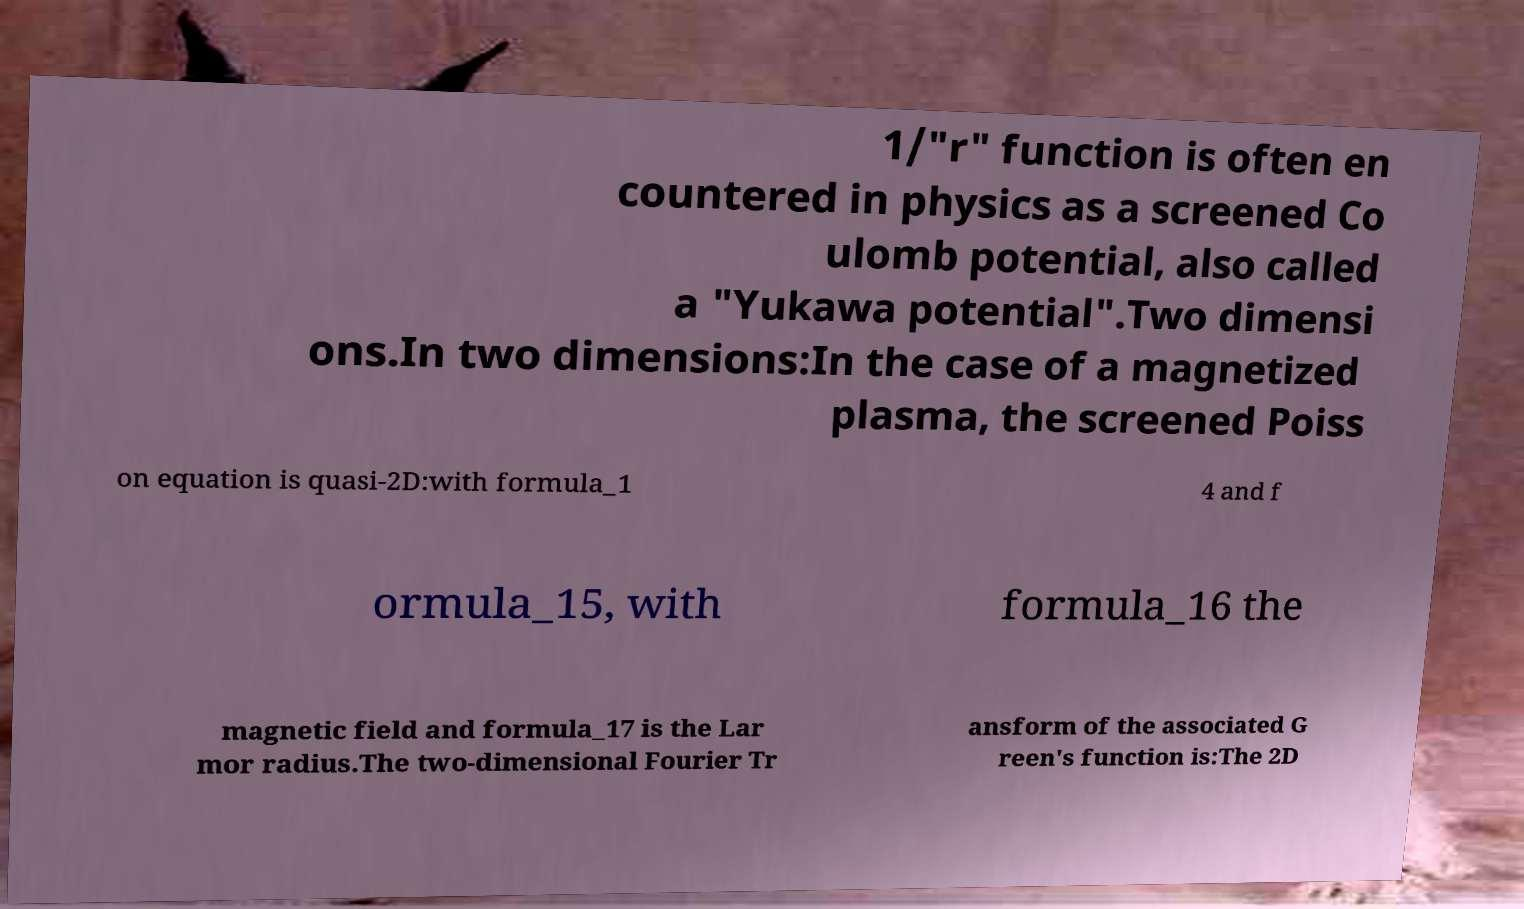Please read and relay the text visible in this image. What does it say? 1/"r" function is often en countered in physics as a screened Co ulomb potential, also called a "Yukawa potential".Two dimensi ons.In two dimensions:In the case of a magnetized plasma, the screened Poiss on equation is quasi-2D:with formula_1 4 and f ormula_15, with formula_16 the magnetic field and formula_17 is the Lar mor radius.The two-dimensional Fourier Tr ansform of the associated G reen's function is:The 2D 